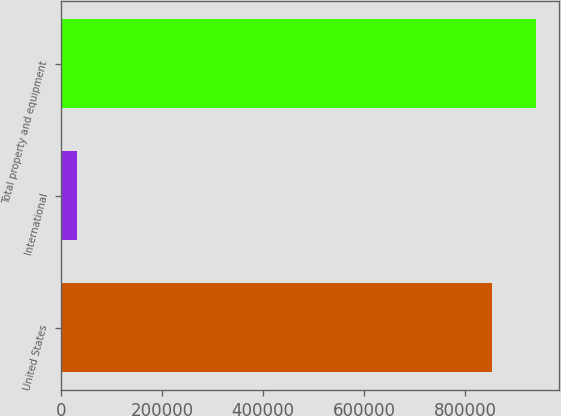<chart> <loc_0><loc_0><loc_500><loc_500><bar_chart><fcel>United States<fcel>International<fcel>Total property and equipment<nl><fcel>853731<fcel>31347<fcel>939104<nl></chart> 